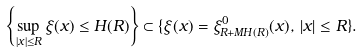Convert formula to latex. <formula><loc_0><loc_0><loc_500><loc_500>\left \{ \sup _ { | x | \leq R } \xi ( x ) \leq H ( R ) \right \} \subset \{ \xi ( x ) = \xi _ { R + M H ( R ) } ^ { 0 } ( x ) , \, | x | \leq R \} .</formula> 